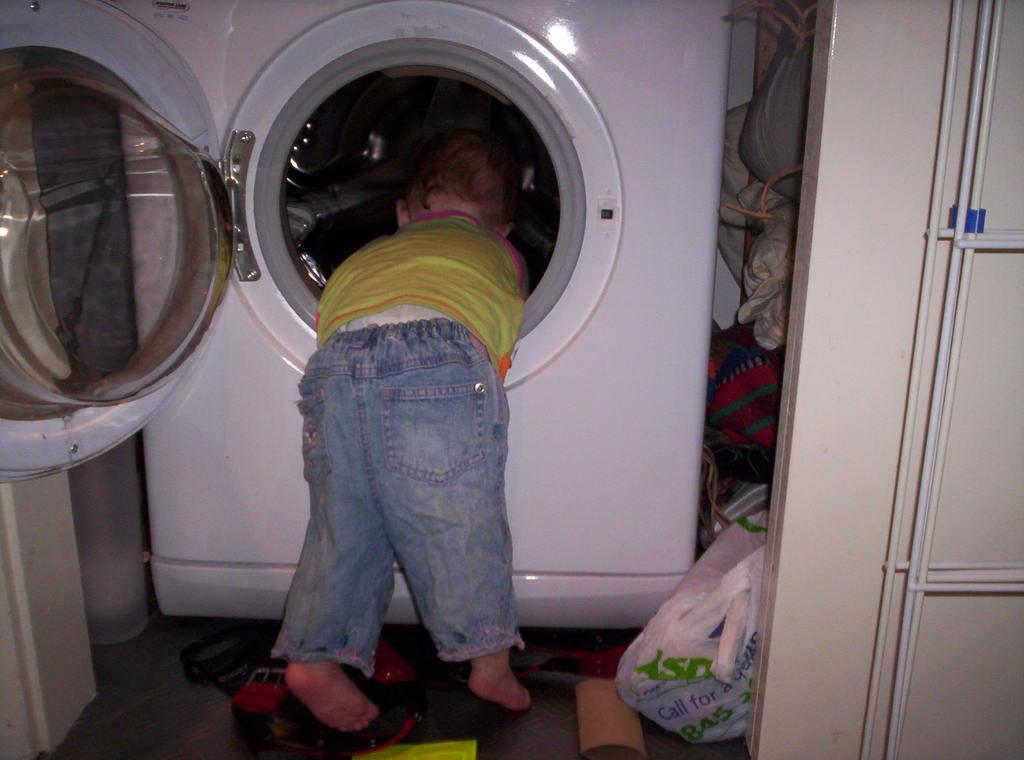Could you give a brief overview of what you see in this image? In the center of the image, we can see a kid bending inside the washing machine and in the background, there are clothes, bags and we can see some other objects on the floor and we can see some pipes on the wall. 